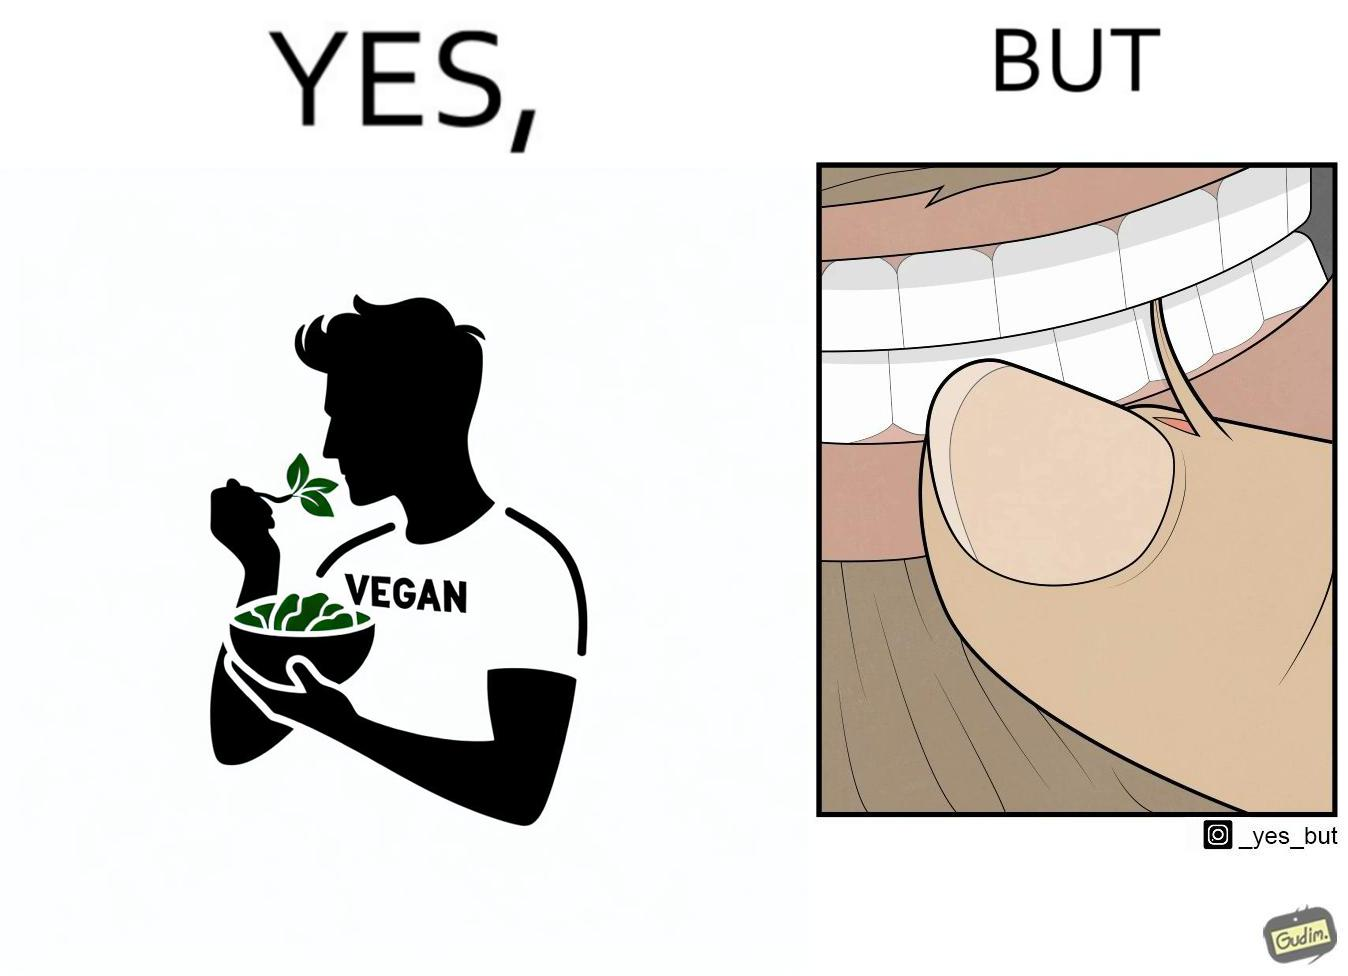Is this image satirical or non-satirical? Yes, this image is satirical. 